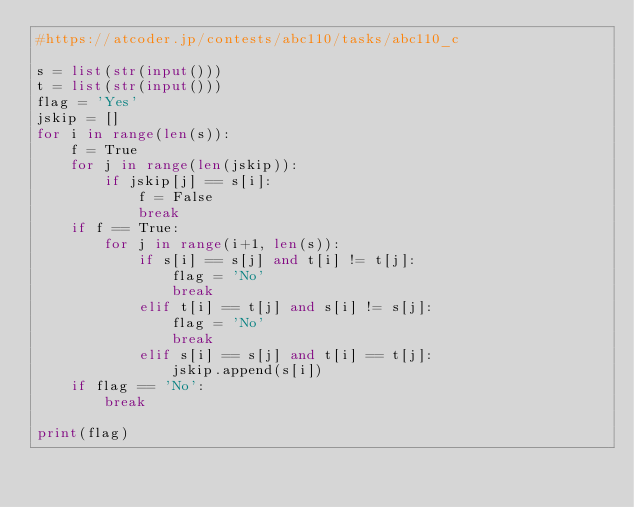Convert code to text. <code><loc_0><loc_0><loc_500><loc_500><_Python_>#https://atcoder.jp/contests/abc110/tasks/abc110_c

s = list(str(input()))
t = list(str(input()))
flag = 'Yes'
jskip = []
for i in range(len(s)):
    f = True
    for j in range(len(jskip)):
        if jskip[j] == s[i]:
            f = False
            break
    if f == True:
        for j in range(i+1, len(s)):
            if s[i] == s[j] and t[i] != t[j]:
                flag = 'No'
                break
            elif t[i] == t[j] and s[i] != s[j]:
                flag = 'No'
                break
            elif s[i] == s[j] and t[i] == t[j]:
                jskip.append(s[i])
    if flag == 'No':
        break

print(flag)
</code> 